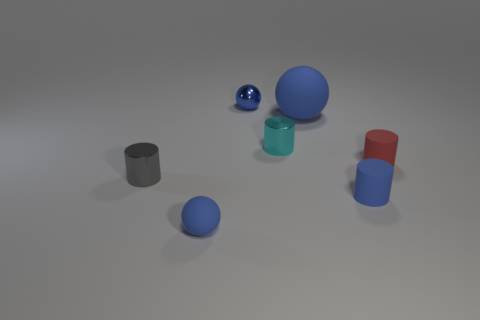How many other objects are there of the same color as the large rubber sphere? Besides the large rubber sphere, there are three other objects that share its blue color: a smaller sphere, a cylinder, and a cube. 